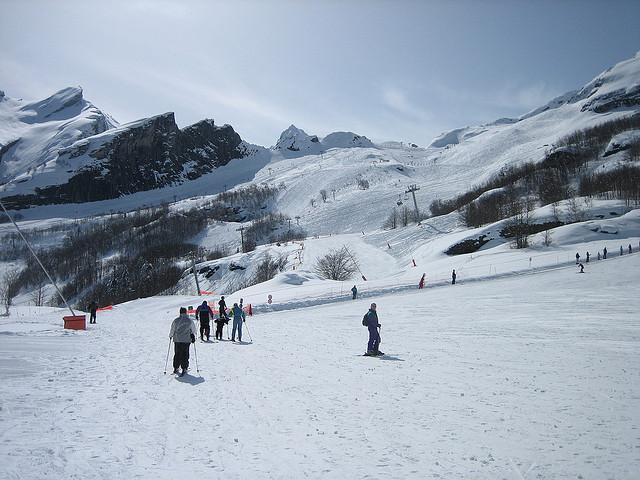What is the elevated metal railway called?

Choices:
A) zip line
B) sky taxi
C) sky elevation
D) ski lift ski lift 